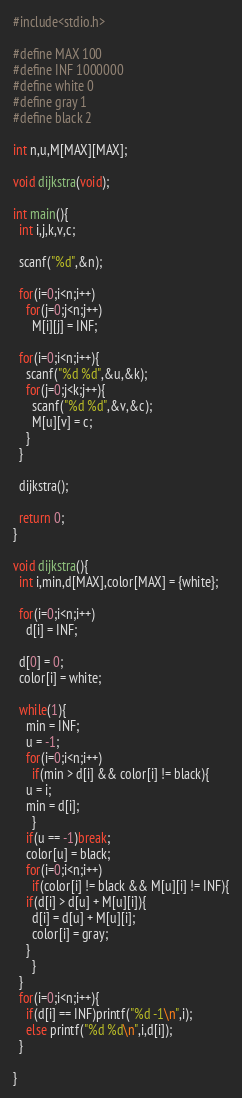<code> <loc_0><loc_0><loc_500><loc_500><_C_>#include<stdio.h>

#define MAX 100
#define INF 1000000
#define white 0
#define gray 1
#define black 2

int n,u,M[MAX][MAX];

void dijkstra(void);

int main(){
  int i,j,k,v,c;

  scanf("%d",&n);

  for(i=0;i<n;i++)
    for(j=0;j<n;j++)
      M[i][j] = INF;

  for(i=0;i<n;i++){
    scanf("%d %d",&u,&k);
    for(j=0;j<k;j++){
      scanf("%d %d",&v,&c);
      M[u][v] = c;
    }
  }

  dijkstra();

  return 0;
}

void dijkstra(){
  int i,min,d[MAX],color[MAX] = {white};

  for(i=0;i<n;i++)
    d[i] = INF;

  d[0] = 0;
  color[i] = white;

  while(1){
    min = INF;
    u = -1;
    for(i=0;i<n;i++)
      if(min > d[i] && color[i] != black){
	u = i;
	min = d[i];
      }
    if(u == -1)break;
    color[u] = black;
    for(i=0;i<n;i++)
      if(color[i] != black && M[u][i] != INF){
	if(d[i] > d[u] + M[u][i]){
	  d[i] = d[u] + M[u][i];
	  color[i] = gray;
	}
      }
  }
  for(i=0;i<n;i++){
    if(d[i] == INF)printf("%d -1\n",i);
    else printf("%d %d\n",i,d[i]);
  }

}</code> 